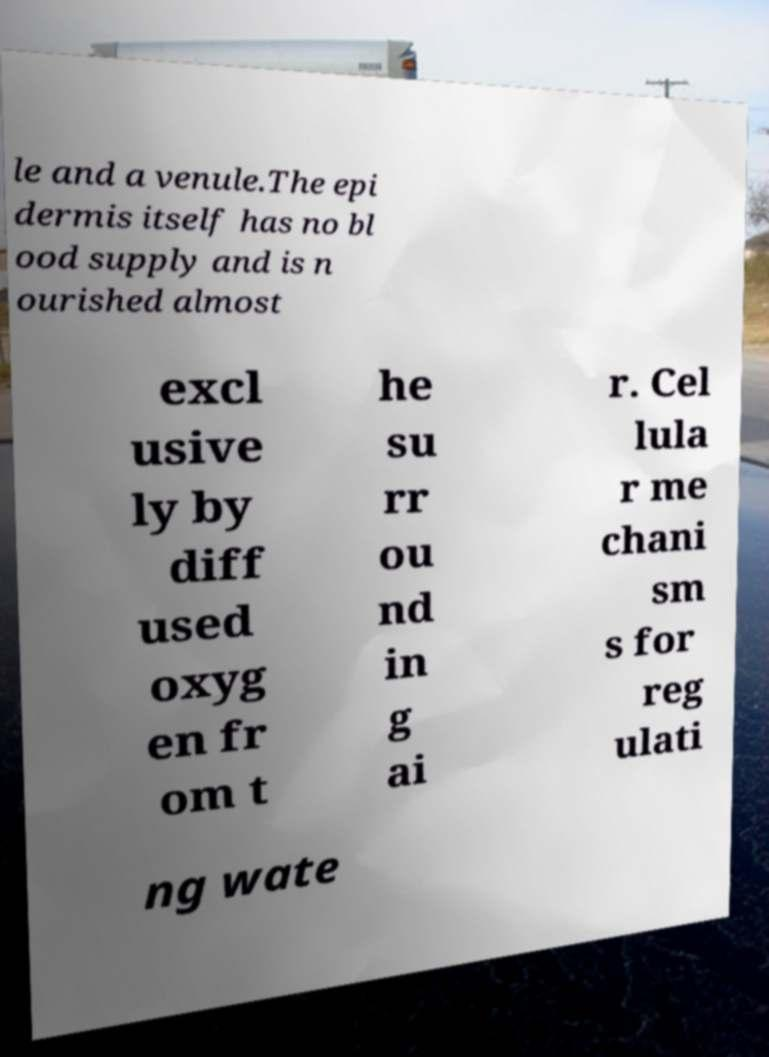There's text embedded in this image that I need extracted. Can you transcribe it verbatim? le and a venule.The epi dermis itself has no bl ood supply and is n ourished almost excl usive ly by diff used oxyg en fr om t he su rr ou nd in g ai r. Cel lula r me chani sm s for reg ulati ng wate 